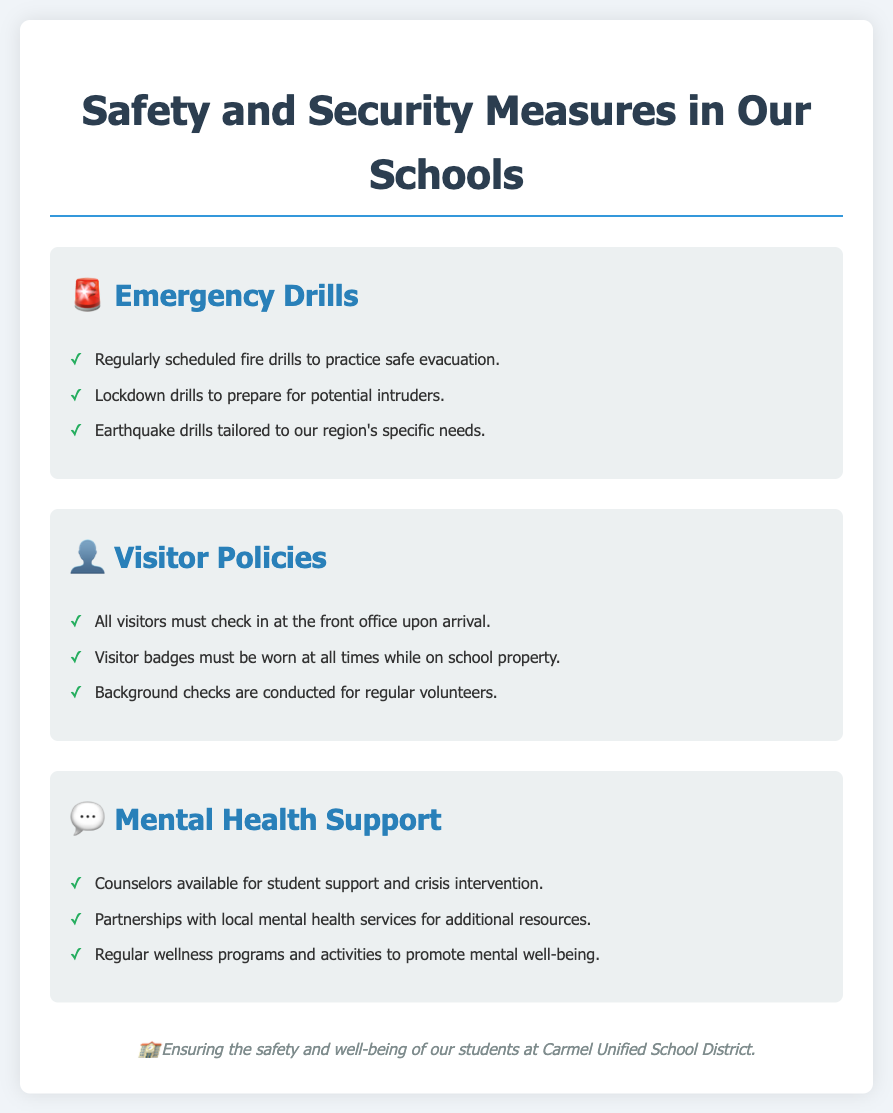What types of drills are mentioned? The document lists emergency drills such as fire drills, lockdown drills, and earthquake drills.
Answer: fire, lockdown, earthquake What must all visitors do upon arrival? The document states that all visitors must check in at the front office upon arrival.
Answer: check in at the front office Who is available for student support? The document indicates that counselors are available for student support and crisis intervention.
Answer: counselors What is a requirement for visitor badges? It states that visitor badges must be worn at all times while on school property.
Answer: worn at all times What type of partnerships does the school district have for mental health? The document mentions partnerships with local mental health services for additional resources.
Answer: local mental health services How often are fire drills scheduled? While the specific frequency is not stated, it implies that they are regularly scheduled.
Answer: regularly What is the purpose of wellness programs? The document indicates that wellness programs and activities aim to promote mental well-being.
Answer: promote mental well-being What icon represents Emergency Drills? The document uses a police car emoji to represent Emergency Drills.
Answer: 🚨 What is the main goal of the safety measures? The flyer clearly states that the overall goal is ensuring the safety and well-being of students.
Answer: safety and well-being What type of intervention is mentioned alongside counselor support? The document mentions crisis intervention as part of the support offered.
Answer: crisis intervention 